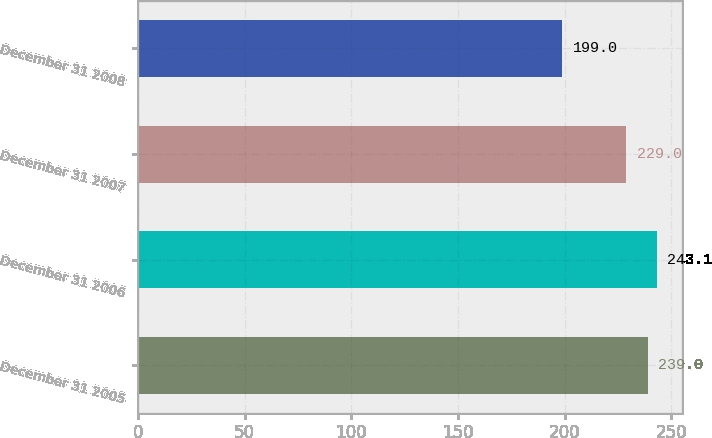<chart> <loc_0><loc_0><loc_500><loc_500><bar_chart><fcel>December 31 2005<fcel>December 31 2006<fcel>December 31 2007<fcel>December 31 2008<nl><fcel>239<fcel>243.1<fcel>229<fcel>199<nl></chart> 